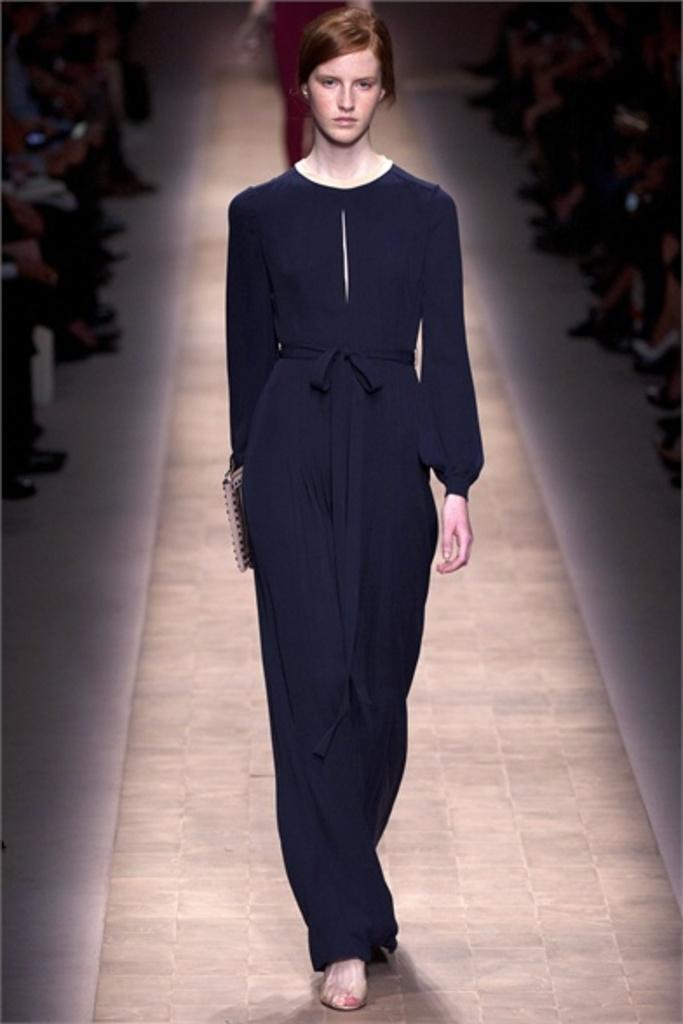What is the main action of the woman in the image? There is a woman walking in the image. Can you describe the background of the image? There is another woman in the background of the image. What are some people in the image doing? There are people sitting in the image. What type of carriage can be seen in the image? There is no carriage present in the image. How many cherries are on the tree in the image? There is no tree or cherries visible in the image. 